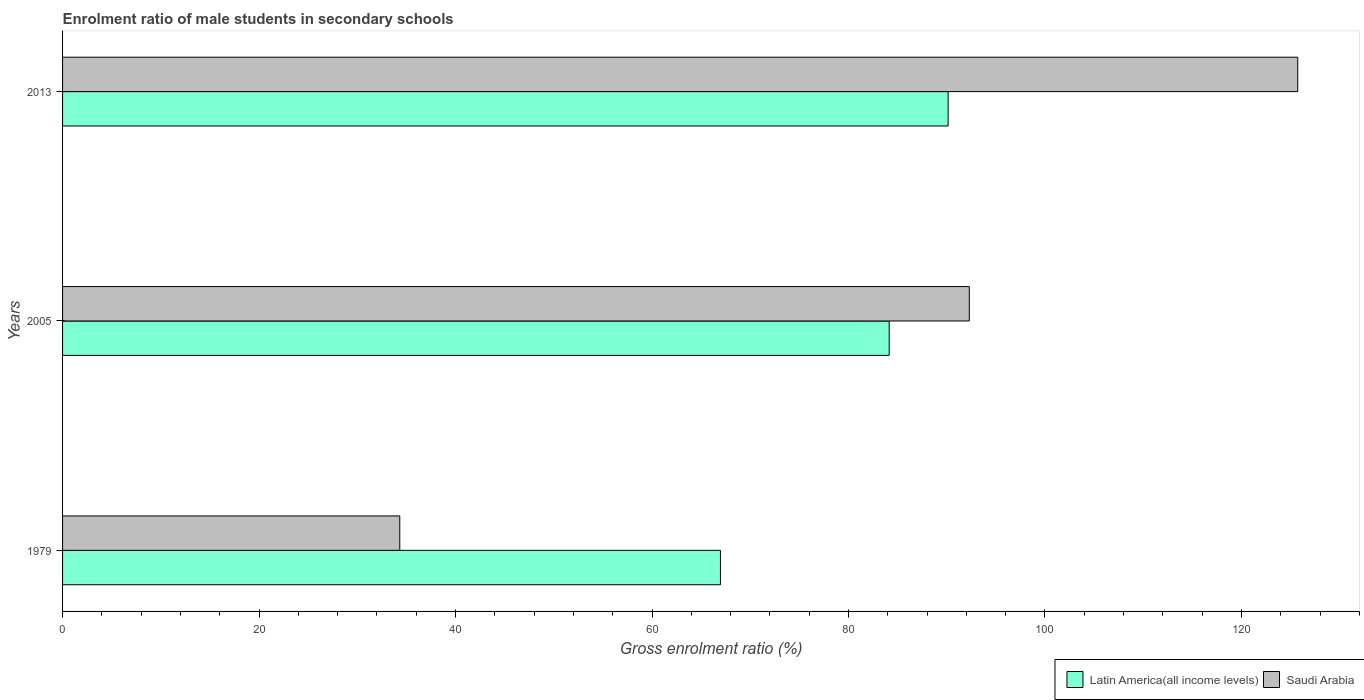How many different coloured bars are there?
Provide a succinct answer. 2. How many groups of bars are there?
Offer a very short reply. 3. Are the number of bars on each tick of the Y-axis equal?
Make the answer very short. Yes. How many bars are there on the 2nd tick from the top?
Ensure brevity in your answer.  2. What is the enrolment ratio of male students in secondary schools in Latin America(all income levels) in 2013?
Your response must be concise. 90.14. Across all years, what is the maximum enrolment ratio of male students in secondary schools in Latin America(all income levels)?
Keep it short and to the point. 90.14. Across all years, what is the minimum enrolment ratio of male students in secondary schools in Latin America(all income levels)?
Your response must be concise. 66.97. In which year was the enrolment ratio of male students in secondary schools in Saudi Arabia minimum?
Provide a succinct answer. 1979. What is the total enrolment ratio of male students in secondary schools in Saudi Arabia in the graph?
Keep it short and to the point. 252.36. What is the difference between the enrolment ratio of male students in secondary schools in Saudi Arabia in 1979 and that in 2005?
Provide a succinct answer. -57.97. What is the difference between the enrolment ratio of male students in secondary schools in Saudi Arabia in 2005 and the enrolment ratio of male students in secondary schools in Latin America(all income levels) in 2013?
Offer a very short reply. 2.16. What is the average enrolment ratio of male students in secondary schools in Latin America(all income levels) per year?
Provide a short and direct response. 80.42. In the year 2005, what is the difference between the enrolment ratio of male students in secondary schools in Saudi Arabia and enrolment ratio of male students in secondary schools in Latin America(all income levels)?
Make the answer very short. 8.15. In how many years, is the enrolment ratio of male students in secondary schools in Saudi Arabia greater than 92 %?
Ensure brevity in your answer.  2. What is the ratio of the enrolment ratio of male students in secondary schools in Latin America(all income levels) in 1979 to that in 2005?
Keep it short and to the point. 0.8. Is the difference between the enrolment ratio of male students in secondary schools in Saudi Arabia in 2005 and 2013 greater than the difference between the enrolment ratio of male students in secondary schools in Latin America(all income levels) in 2005 and 2013?
Make the answer very short. No. What is the difference between the highest and the second highest enrolment ratio of male students in secondary schools in Latin America(all income levels)?
Your answer should be compact. 6. What is the difference between the highest and the lowest enrolment ratio of male students in secondary schools in Saudi Arabia?
Your answer should be compact. 91.41. Is the sum of the enrolment ratio of male students in secondary schools in Latin America(all income levels) in 1979 and 2005 greater than the maximum enrolment ratio of male students in secondary schools in Saudi Arabia across all years?
Keep it short and to the point. Yes. What does the 1st bar from the top in 2013 represents?
Keep it short and to the point. Saudi Arabia. What does the 2nd bar from the bottom in 2013 represents?
Keep it short and to the point. Saudi Arabia. Are all the bars in the graph horizontal?
Ensure brevity in your answer.  Yes. What is the difference between two consecutive major ticks on the X-axis?
Your response must be concise. 20. Does the graph contain grids?
Offer a very short reply. No. How many legend labels are there?
Offer a terse response. 2. How are the legend labels stacked?
Your answer should be compact. Horizontal. What is the title of the graph?
Offer a terse response. Enrolment ratio of male students in secondary schools. Does "Switzerland" appear as one of the legend labels in the graph?
Ensure brevity in your answer.  No. What is the label or title of the Y-axis?
Ensure brevity in your answer.  Years. What is the Gross enrolment ratio (%) in Latin America(all income levels) in 1979?
Offer a terse response. 66.97. What is the Gross enrolment ratio (%) of Saudi Arabia in 1979?
Your answer should be compact. 34.33. What is the Gross enrolment ratio (%) of Latin America(all income levels) in 2005?
Offer a very short reply. 84.14. What is the Gross enrolment ratio (%) in Saudi Arabia in 2005?
Provide a succinct answer. 92.3. What is the Gross enrolment ratio (%) of Latin America(all income levels) in 2013?
Your answer should be compact. 90.14. What is the Gross enrolment ratio (%) of Saudi Arabia in 2013?
Your answer should be compact. 125.73. Across all years, what is the maximum Gross enrolment ratio (%) in Latin America(all income levels)?
Provide a short and direct response. 90.14. Across all years, what is the maximum Gross enrolment ratio (%) in Saudi Arabia?
Your answer should be compact. 125.73. Across all years, what is the minimum Gross enrolment ratio (%) in Latin America(all income levels)?
Make the answer very short. 66.97. Across all years, what is the minimum Gross enrolment ratio (%) of Saudi Arabia?
Keep it short and to the point. 34.33. What is the total Gross enrolment ratio (%) in Latin America(all income levels) in the graph?
Provide a short and direct response. 241.25. What is the total Gross enrolment ratio (%) in Saudi Arabia in the graph?
Your answer should be very brief. 252.36. What is the difference between the Gross enrolment ratio (%) in Latin America(all income levels) in 1979 and that in 2005?
Provide a short and direct response. -17.18. What is the difference between the Gross enrolment ratio (%) in Saudi Arabia in 1979 and that in 2005?
Your response must be concise. -57.97. What is the difference between the Gross enrolment ratio (%) in Latin America(all income levels) in 1979 and that in 2013?
Offer a terse response. -23.18. What is the difference between the Gross enrolment ratio (%) of Saudi Arabia in 1979 and that in 2013?
Ensure brevity in your answer.  -91.41. What is the difference between the Gross enrolment ratio (%) in Latin America(all income levels) in 2005 and that in 2013?
Your answer should be compact. -6. What is the difference between the Gross enrolment ratio (%) of Saudi Arabia in 2005 and that in 2013?
Offer a terse response. -33.43. What is the difference between the Gross enrolment ratio (%) of Latin America(all income levels) in 1979 and the Gross enrolment ratio (%) of Saudi Arabia in 2005?
Your answer should be compact. -25.33. What is the difference between the Gross enrolment ratio (%) of Latin America(all income levels) in 1979 and the Gross enrolment ratio (%) of Saudi Arabia in 2013?
Your response must be concise. -58.77. What is the difference between the Gross enrolment ratio (%) in Latin America(all income levels) in 2005 and the Gross enrolment ratio (%) in Saudi Arabia in 2013?
Your response must be concise. -41.59. What is the average Gross enrolment ratio (%) of Latin America(all income levels) per year?
Keep it short and to the point. 80.42. What is the average Gross enrolment ratio (%) of Saudi Arabia per year?
Offer a very short reply. 84.12. In the year 1979, what is the difference between the Gross enrolment ratio (%) of Latin America(all income levels) and Gross enrolment ratio (%) of Saudi Arabia?
Provide a short and direct response. 32.64. In the year 2005, what is the difference between the Gross enrolment ratio (%) in Latin America(all income levels) and Gross enrolment ratio (%) in Saudi Arabia?
Offer a terse response. -8.15. In the year 2013, what is the difference between the Gross enrolment ratio (%) of Latin America(all income levels) and Gross enrolment ratio (%) of Saudi Arabia?
Offer a terse response. -35.59. What is the ratio of the Gross enrolment ratio (%) in Latin America(all income levels) in 1979 to that in 2005?
Make the answer very short. 0.8. What is the ratio of the Gross enrolment ratio (%) in Saudi Arabia in 1979 to that in 2005?
Your answer should be compact. 0.37. What is the ratio of the Gross enrolment ratio (%) of Latin America(all income levels) in 1979 to that in 2013?
Give a very brief answer. 0.74. What is the ratio of the Gross enrolment ratio (%) of Saudi Arabia in 1979 to that in 2013?
Keep it short and to the point. 0.27. What is the ratio of the Gross enrolment ratio (%) in Latin America(all income levels) in 2005 to that in 2013?
Your answer should be very brief. 0.93. What is the ratio of the Gross enrolment ratio (%) of Saudi Arabia in 2005 to that in 2013?
Make the answer very short. 0.73. What is the difference between the highest and the second highest Gross enrolment ratio (%) in Latin America(all income levels)?
Provide a short and direct response. 6. What is the difference between the highest and the second highest Gross enrolment ratio (%) in Saudi Arabia?
Ensure brevity in your answer.  33.43. What is the difference between the highest and the lowest Gross enrolment ratio (%) in Latin America(all income levels)?
Offer a very short reply. 23.18. What is the difference between the highest and the lowest Gross enrolment ratio (%) in Saudi Arabia?
Provide a short and direct response. 91.41. 